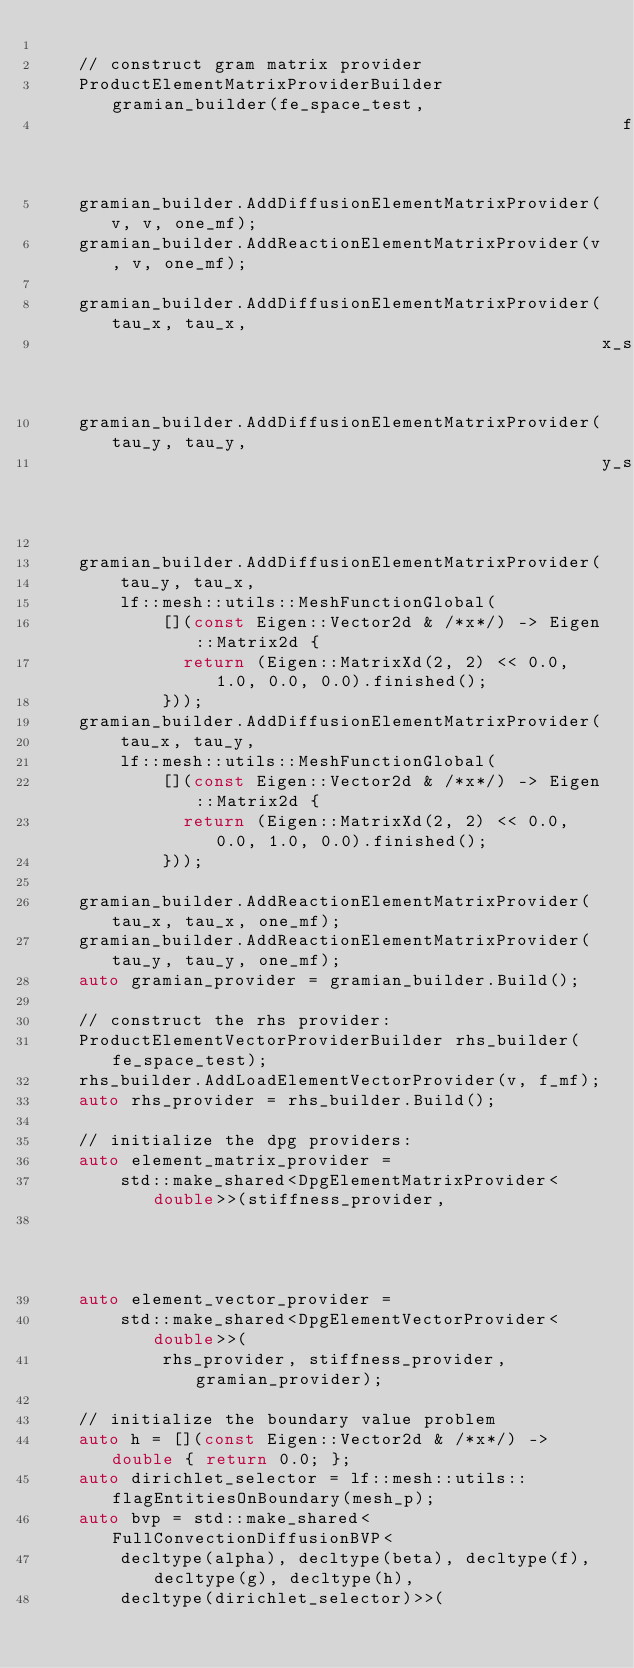<code> <loc_0><loc_0><loc_500><loc_500><_C_>
    // construct gram matrix provider
    ProductElementMatrixProviderBuilder gramian_builder(fe_space_test,
                                                        fe_space_test);
    gramian_builder.AddDiffusionElementMatrixProvider(v, v, one_mf);
    gramian_builder.AddReactionElementMatrixProvider(v, v, one_mf);

    gramian_builder.AddDiffusionElementMatrixProvider(tau_x, tau_x,
                                                      x_selector_mf);
    gramian_builder.AddDiffusionElementMatrixProvider(tau_y, tau_y,
                                                      y_selector_mf);

    gramian_builder.AddDiffusionElementMatrixProvider(
        tau_y, tau_x,
        lf::mesh::utils::MeshFunctionGlobal(
            [](const Eigen::Vector2d & /*x*/) -> Eigen::Matrix2d {
              return (Eigen::MatrixXd(2, 2) << 0.0, 1.0, 0.0, 0.0).finished();
            }));
    gramian_builder.AddDiffusionElementMatrixProvider(
        tau_x, tau_y,
        lf::mesh::utils::MeshFunctionGlobal(
            [](const Eigen::Vector2d & /*x*/) -> Eigen::Matrix2d {
              return (Eigen::MatrixXd(2, 2) << 0.0, 0.0, 1.0, 0.0).finished();
            }));

    gramian_builder.AddReactionElementMatrixProvider(tau_x, tau_x, one_mf);
    gramian_builder.AddReactionElementMatrixProvider(tau_y, tau_y, one_mf);
    auto gramian_provider = gramian_builder.Build();

    // construct the rhs provider:
    ProductElementVectorProviderBuilder rhs_builder(fe_space_test);
    rhs_builder.AddLoadElementVectorProvider(v, f_mf);
    auto rhs_provider = rhs_builder.Build();

    // initialize the dpg providers:
    auto element_matrix_provider =
        std::make_shared<DpgElementMatrixProvider<double>>(stiffness_provider,
                                                           gramian_provider);
    auto element_vector_provider =
        std::make_shared<DpgElementVectorProvider<double>>(
            rhs_provider, stiffness_provider, gramian_provider);

    // initialize the boundary value problem
    auto h = [](const Eigen::Vector2d & /*x*/) -> double { return 0.0; };
    auto dirichlet_selector = lf::mesh::utils::flagEntitiesOnBoundary(mesh_p);
    auto bvp = std::make_shared<FullConvectionDiffusionBVP<
        decltype(alpha), decltype(beta), decltype(f), decltype(g), decltype(h),
        decltype(dirichlet_selector)>>(</code> 